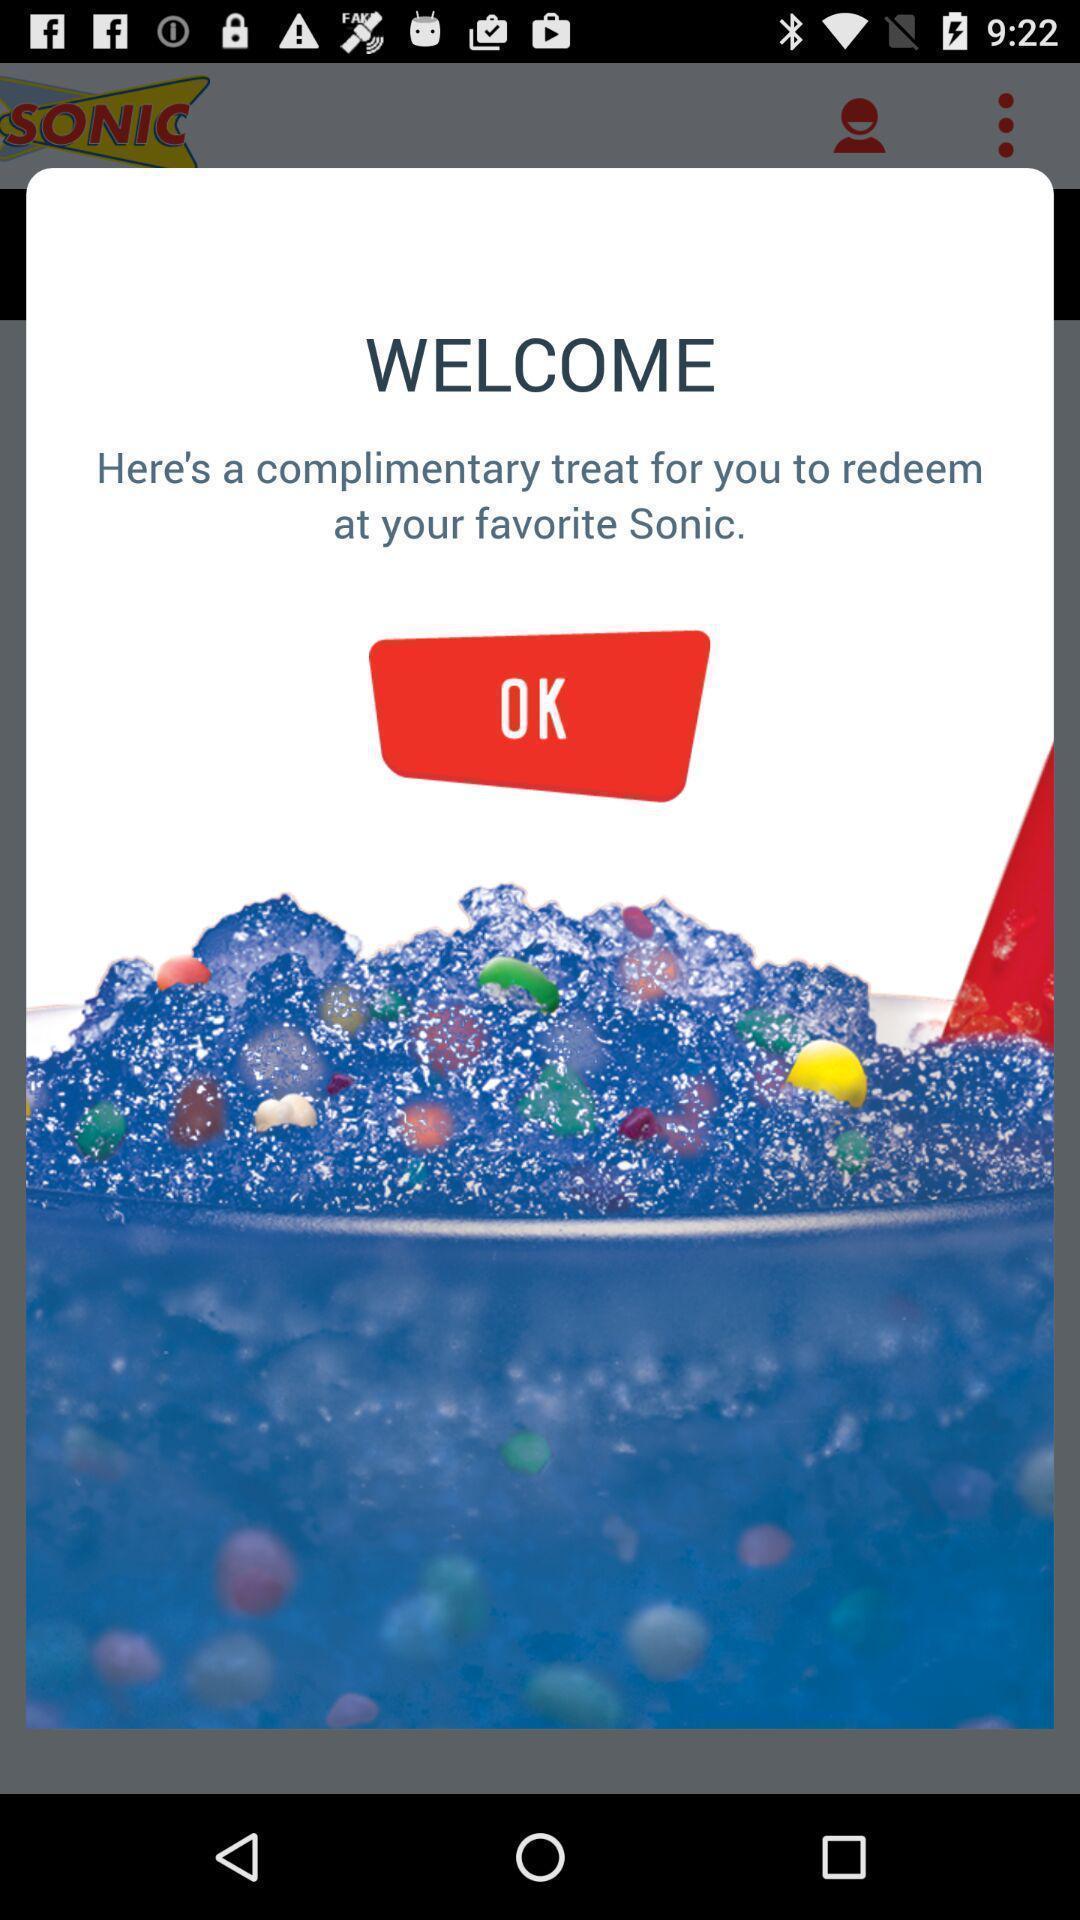Please provide a description for this image. Welcome page. 